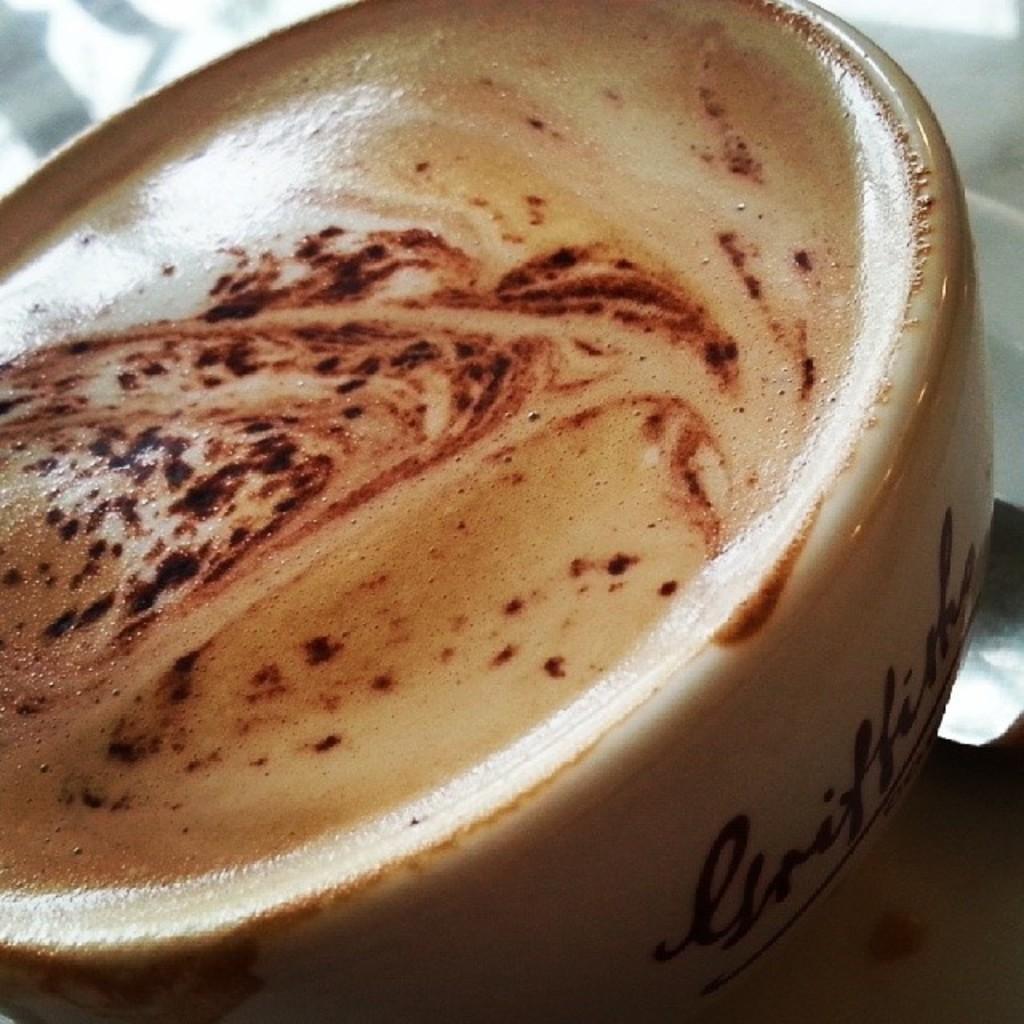How would you summarize this image in a sentence or two? In the foreground of this image, there is a coffee cup on an object and the background image is not clear. 